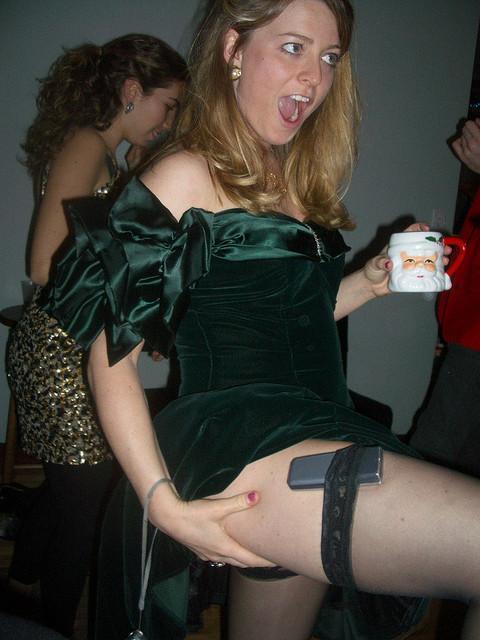How many people are in the picture?
Give a very brief answer. 3. How many black umbrellas are there?
Give a very brief answer. 0. 